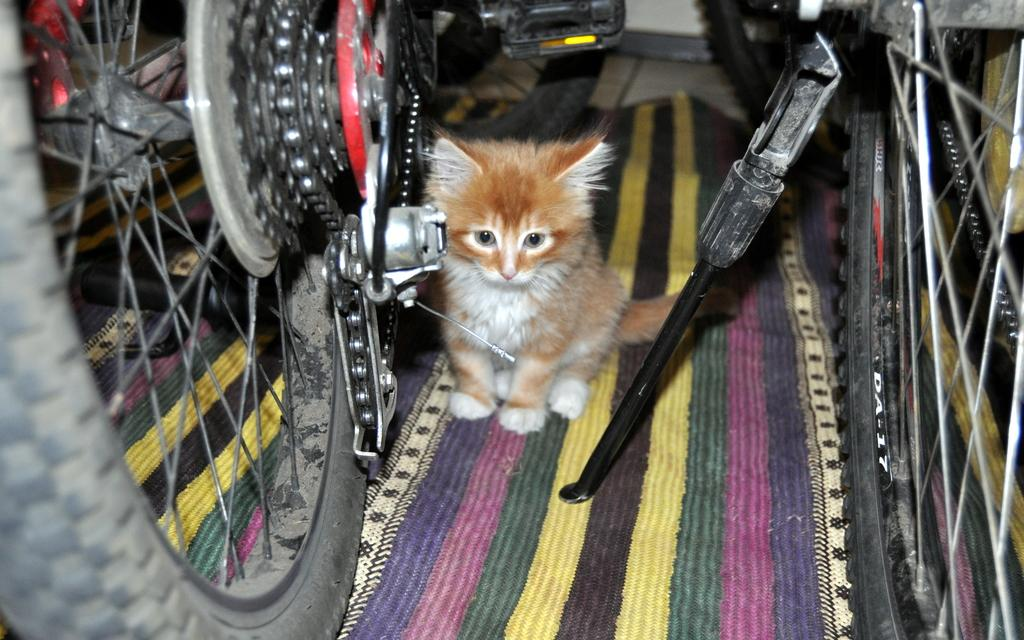What animal is present in the image? There is a cat in the image. Where is the cat located? The cat is sitting on a mat. What else can be seen in the image besides the cat? There are two bicycles in the image. What type of plants can be seen growing on the cat in the image? There are no plants visible on the cat in the image. 